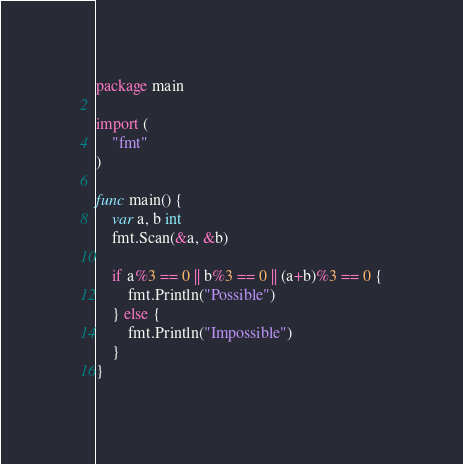<code> <loc_0><loc_0><loc_500><loc_500><_Go_>package main

import (
	"fmt"
)

func main() {
	var a, b int
	fmt.Scan(&a, &b)

	if a%3 == 0 || b%3 == 0 || (a+b)%3 == 0 {
		fmt.Println("Possible")
	} else {
		fmt.Println("Impossible")
	}
}
</code> 